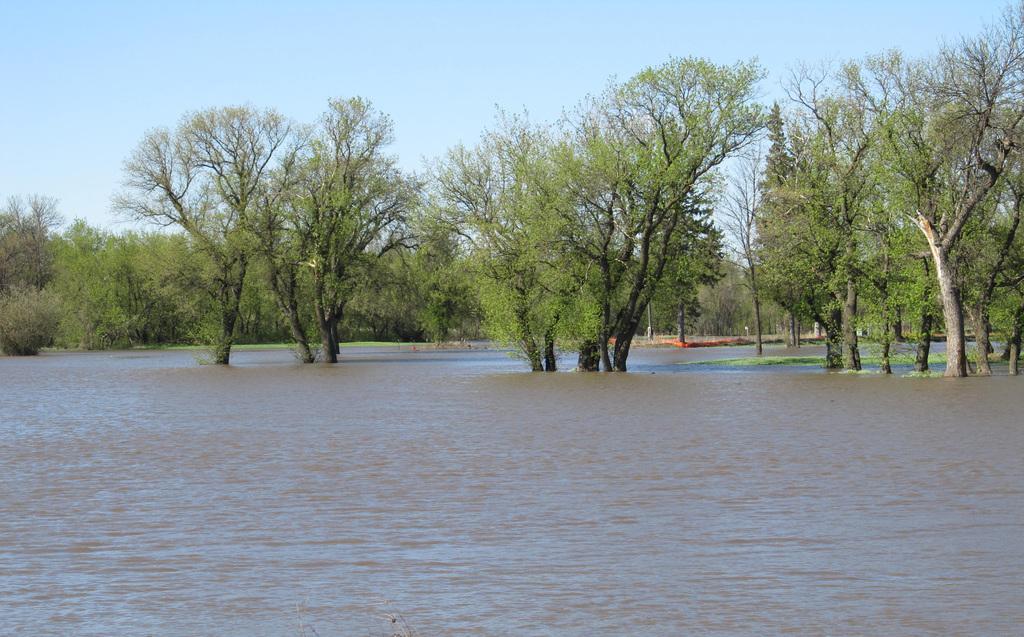How would you summarize this image in a sentence or two? At the bottom of this image I can see a river. In the background there are many trees. At the top I can see the sky. 